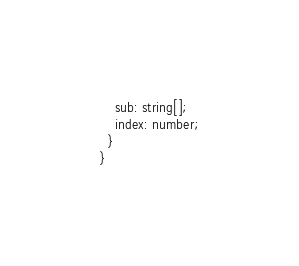<code> <loc_0><loc_0><loc_500><loc_500><_JavaScript_>    sub: string[];
    index: number;
  }
}
</code> 